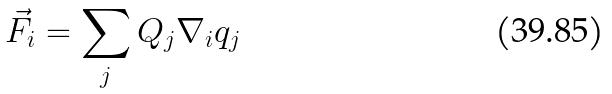Convert formula to latex. <formula><loc_0><loc_0><loc_500><loc_500>\vec { F } _ { i } = \sum _ { j } Q _ { j } \nabla _ { i } q _ { j }</formula> 